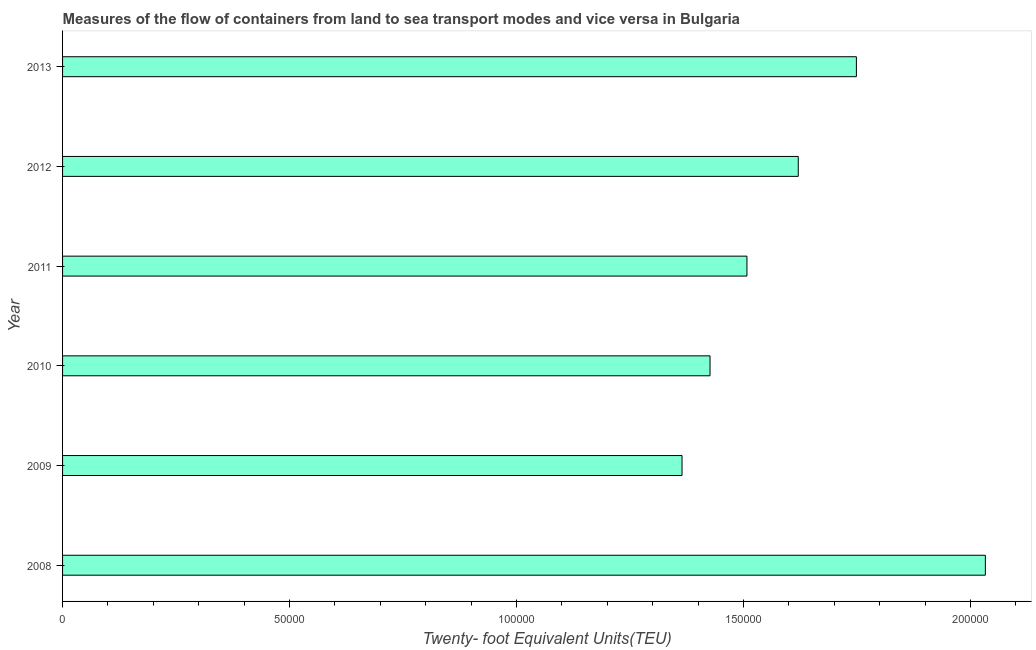What is the title of the graph?
Provide a succinct answer. Measures of the flow of containers from land to sea transport modes and vice versa in Bulgaria. What is the label or title of the X-axis?
Make the answer very short. Twenty- foot Equivalent Units(TEU). What is the label or title of the Y-axis?
Keep it short and to the point. Year. What is the container port traffic in 2008?
Your response must be concise. 2.03e+05. Across all years, what is the maximum container port traffic?
Your response must be concise. 2.03e+05. Across all years, what is the minimum container port traffic?
Offer a very short reply. 1.36e+05. What is the sum of the container port traffic?
Provide a succinct answer. 9.70e+05. What is the difference between the container port traffic in 2008 and 2011?
Your answer should be compact. 5.25e+04. What is the average container port traffic per year?
Provide a succinct answer. 1.62e+05. What is the median container port traffic?
Provide a short and direct response. 1.56e+05. What is the ratio of the container port traffic in 2009 to that in 2013?
Your answer should be very brief. 0.78. Is the container port traffic in 2010 less than that in 2013?
Your answer should be compact. Yes. Is the difference between the container port traffic in 2008 and 2013 greater than the difference between any two years?
Provide a succinct answer. No. What is the difference between the highest and the second highest container port traffic?
Make the answer very short. 2.84e+04. Is the sum of the container port traffic in 2009 and 2012 greater than the maximum container port traffic across all years?
Keep it short and to the point. Yes. What is the difference between the highest and the lowest container port traffic?
Offer a very short reply. 6.68e+04. How many bars are there?
Ensure brevity in your answer.  6. Are all the bars in the graph horizontal?
Offer a terse response. Yes. What is the difference between two consecutive major ticks on the X-axis?
Ensure brevity in your answer.  5.00e+04. Are the values on the major ticks of X-axis written in scientific E-notation?
Your answer should be compact. No. What is the Twenty- foot Equivalent Units(TEU) in 2008?
Keep it short and to the point. 2.03e+05. What is the Twenty- foot Equivalent Units(TEU) in 2009?
Provide a succinct answer. 1.36e+05. What is the Twenty- foot Equivalent Units(TEU) in 2010?
Keep it short and to the point. 1.43e+05. What is the Twenty- foot Equivalent Units(TEU) in 2011?
Ensure brevity in your answer.  1.51e+05. What is the Twenty- foot Equivalent Units(TEU) of 2012?
Your answer should be very brief. 1.62e+05. What is the Twenty- foot Equivalent Units(TEU) of 2013?
Offer a terse response. 1.75e+05. What is the difference between the Twenty- foot Equivalent Units(TEU) in 2008 and 2009?
Provide a succinct answer. 6.68e+04. What is the difference between the Twenty- foot Equivalent Units(TEU) in 2008 and 2010?
Ensure brevity in your answer.  6.06e+04. What is the difference between the Twenty- foot Equivalent Units(TEU) in 2008 and 2011?
Keep it short and to the point. 5.25e+04. What is the difference between the Twenty- foot Equivalent Units(TEU) in 2008 and 2012?
Offer a very short reply. 4.12e+04. What is the difference between the Twenty- foot Equivalent Units(TEU) in 2008 and 2013?
Keep it short and to the point. 2.84e+04. What is the difference between the Twenty- foot Equivalent Units(TEU) in 2009 and 2010?
Your response must be concise. -6167. What is the difference between the Twenty- foot Equivalent Units(TEU) in 2009 and 2011?
Offer a very short reply. -1.43e+04. What is the difference between the Twenty- foot Equivalent Units(TEU) in 2009 and 2012?
Your answer should be compact. -2.56e+04. What is the difference between the Twenty- foot Equivalent Units(TEU) in 2009 and 2013?
Give a very brief answer. -3.84e+04. What is the difference between the Twenty- foot Equivalent Units(TEU) in 2010 and 2011?
Keep it short and to the point. -8128.83. What is the difference between the Twenty- foot Equivalent Units(TEU) in 2010 and 2012?
Your response must be concise. -1.94e+04. What is the difference between the Twenty- foot Equivalent Units(TEU) in 2010 and 2013?
Keep it short and to the point. -3.22e+04. What is the difference between the Twenty- foot Equivalent Units(TEU) in 2011 and 2012?
Offer a terse response. -1.13e+04. What is the difference between the Twenty- foot Equivalent Units(TEU) in 2011 and 2013?
Your response must be concise. -2.41e+04. What is the difference between the Twenty- foot Equivalent Units(TEU) in 2012 and 2013?
Your response must be concise. -1.28e+04. What is the ratio of the Twenty- foot Equivalent Units(TEU) in 2008 to that in 2009?
Ensure brevity in your answer.  1.49. What is the ratio of the Twenty- foot Equivalent Units(TEU) in 2008 to that in 2010?
Ensure brevity in your answer.  1.43. What is the ratio of the Twenty- foot Equivalent Units(TEU) in 2008 to that in 2011?
Offer a very short reply. 1.35. What is the ratio of the Twenty- foot Equivalent Units(TEU) in 2008 to that in 2012?
Offer a terse response. 1.25. What is the ratio of the Twenty- foot Equivalent Units(TEU) in 2008 to that in 2013?
Your answer should be very brief. 1.16. What is the ratio of the Twenty- foot Equivalent Units(TEU) in 2009 to that in 2011?
Keep it short and to the point. 0.91. What is the ratio of the Twenty- foot Equivalent Units(TEU) in 2009 to that in 2012?
Keep it short and to the point. 0.84. What is the ratio of the Twenty- foot Equivalent Units(TEU) in 2009 to that in 2013?
Offer a terse response. 0.78. What is the ratio of the Twenty- foot Equivalent Units(TEU) in 2010 to that in 2011?
Provide a succinct answer. 0.95. What is the ratio of the Twenty- foot Equivalent Units(TEU) in 2010 to that in 2013?
Ensure brevity in your answer.  0.82. What is the ratio of the Twenty- foot Equivalent Units(TEU) in 2011 to that in 2012?
Keep it short and to the point. 0.93. What is the ratio of the Twenty- foot Equivalent Units(TEU) in 2011 to that in 2013?
Your answer should be very brief. 0.86. What is the ratio of the Twenty- foot Equivalent Units(TEU) in 2012 to that in 2013?
Offer a terse response. 0.93. 